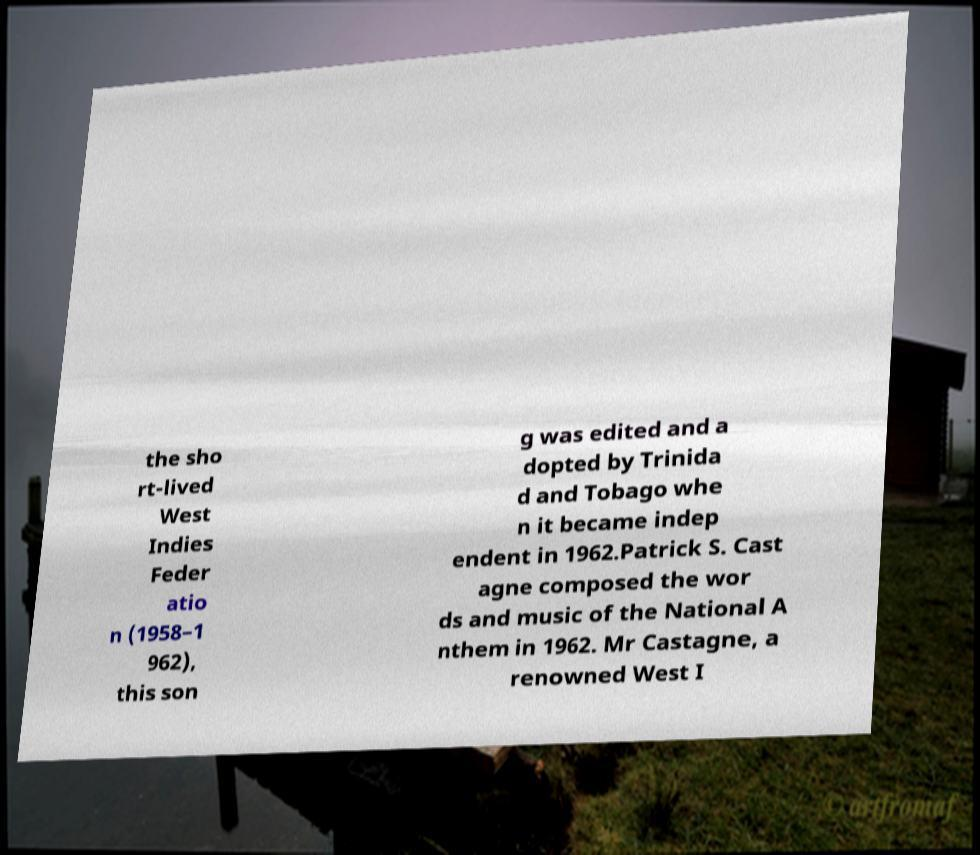Can you accurately transcribe the text from the provided image for me? the sho rt-lived West Indies Feder atio n (1958–1 962), this son g was edited and a dopted by Trinida d and Tobago whe n it became indep endent in 1962.Patrick S. Cast agne composed the wor ds and music of the National A nthem in 1962. Mr Castagne, a renowned West I 